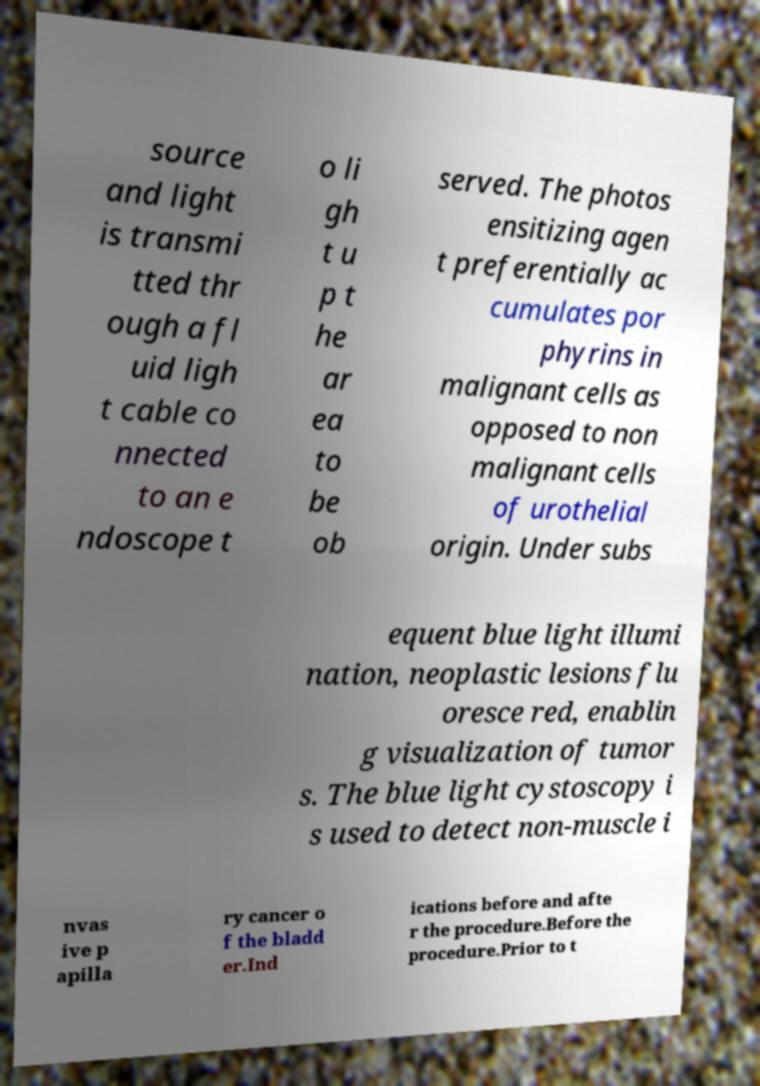I need the written content from this picture converted into text. Can you do that? source and light is transmi tted thr ough a fl uid ligh t cable co nnected to an e ndoscope t o li gh t u p t he ar ea to be ob served. The photos ensitizing agen t preferentially ac cumulates por phyrins in malignant cells as opposed to non malignant cells of urothelial origin. Under subs equent blue light illumi nation, neoplastic lesions flu oresce red, enablin g visualization of tumor s. The blue light cystoscopy i s used to detect non-muscle i nvas ive p apilla ry cancer o f the bladd er.Ind ications before and afte r the procedure.Before the procedure.Prior to t 